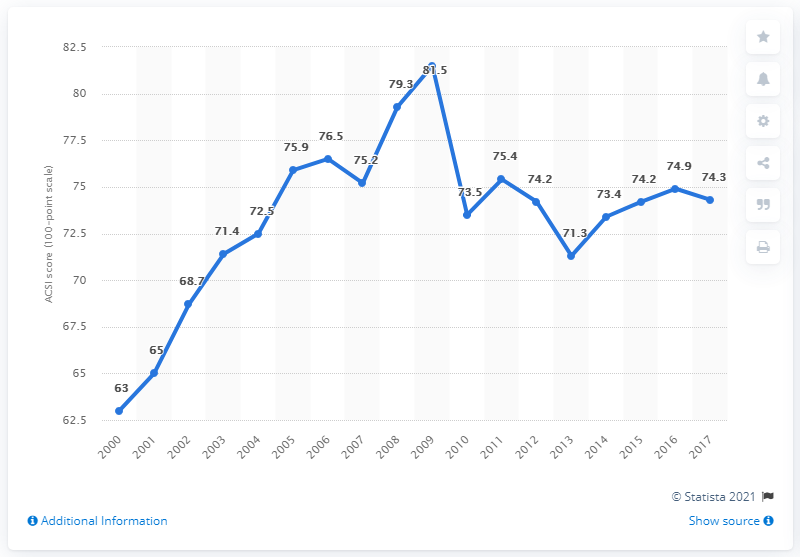What trend in customer satisfaction does the graph show from 2001 to 2017? The graph illustrates a generally upward trend in customer satisfaction from 2001, starting at 63, to a peak in 2011 at 81.5. After 2011, there is some fluctuation, but the overall trend remains positive despite some years of decline, like in 2012 and 2017, ending with a score of 74.3.  Are there any notable fluctuations in customer satisfaction over the years? Yes, there are notable changes in the customer satisfaction scores. For example, after a steady increase, there's a sharp decrease from 81.5 in 2011 to 73.5 in 2012. Another interesting observation is that after a period of recovery, there’s a slight dip from 74.9 in 2016 to 74.3 in 2017. 